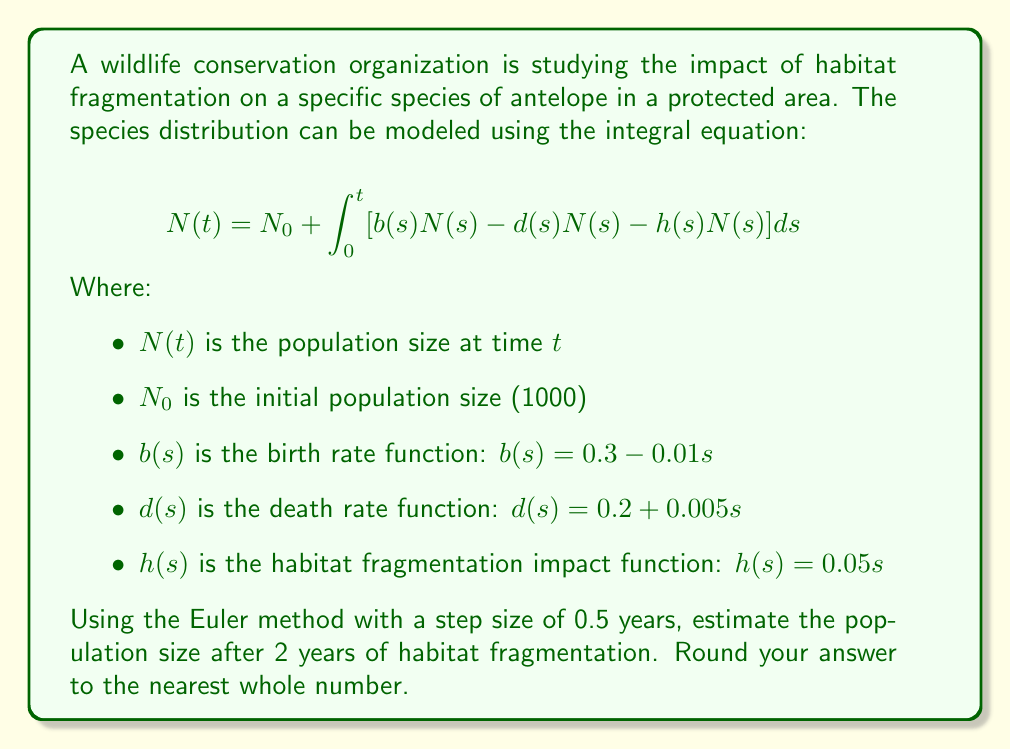Can you answer this question? To solve this problem using the Euler method, we'll follow these steps:

1) The Euler method for this integral equation is:
   $$N(t_{i+1}) = N(t_i) + [b(t_i)N(t_i) - d(t_i)N(t_i) - h(t_i)N(t_i)] \Delta t$$

2) Given:
   - Initial population $N_0 = 1000$
   - Step size $\Delta t = 0.5$ years
   - We need to calculate for 2 years, so we'll have 4 steps

3) Let's calculate for each step:

   Step 1 ($t = 0.5$):
   $b(0.5) = 0.3 - 0.01(0.5) = 0.295$
   $d(0.5) = 0.2 + 0.005(0.5) = 0.2025$
   $h(0.5) = 0.05(0.5) = 0.025$
   $N(0.5) = 1000 + [0.295(1000) - 0.2025(1000) - 0.025(1000)] * 0.5 = 1033.75$

   Step 2 ($t = 1.0$):
   $b(1.0) = 0.3 - 0.01(1.0) = 0.29$
   $d(1.0) = 0.2 + 0.005(1.0) = 0.205$
   $h(1.0) = 0.05(1.0) = 0.05$
   $N(1.0) = 1033.75 + [0.29(1033.75) - 0.205(1033.75) - 0.05(1033.75)] * 0.5 = 1051.09$

   Step 3 ($t = 1.5$):
   $b(1.5) = 0.3 - 0.01(1.5) = 0.285$
   $d(1.5) = 0.2 + 0.005(1.5) = 0.2075$
   $h(1.5) = 0.05(1.5) = 0.075$
   $N(1.5) = 1051.09 + [0.285(1051.09) - 0.2075(1051.09) - 0.075(1051.09)] * 0.5 = 1051.09$

   Step 4 ($t = 2.0$):
   $b(2.0) = 0.3 - 0.01(2.0) = 0.28$
   $d(2.0) = 0.2 + 0.005(2.0) = 0.21$
   $h(2.0) = 0.05(2.0) = 0.1$
   $N(2.0) = 1051.09 + [0.28(1051.09) - 0.21(1051.09) - 0.1(1051.09)] * 0.5 = 1035.82$

4) Rounding to the nearest whole number: 1036
Answer: 1036 